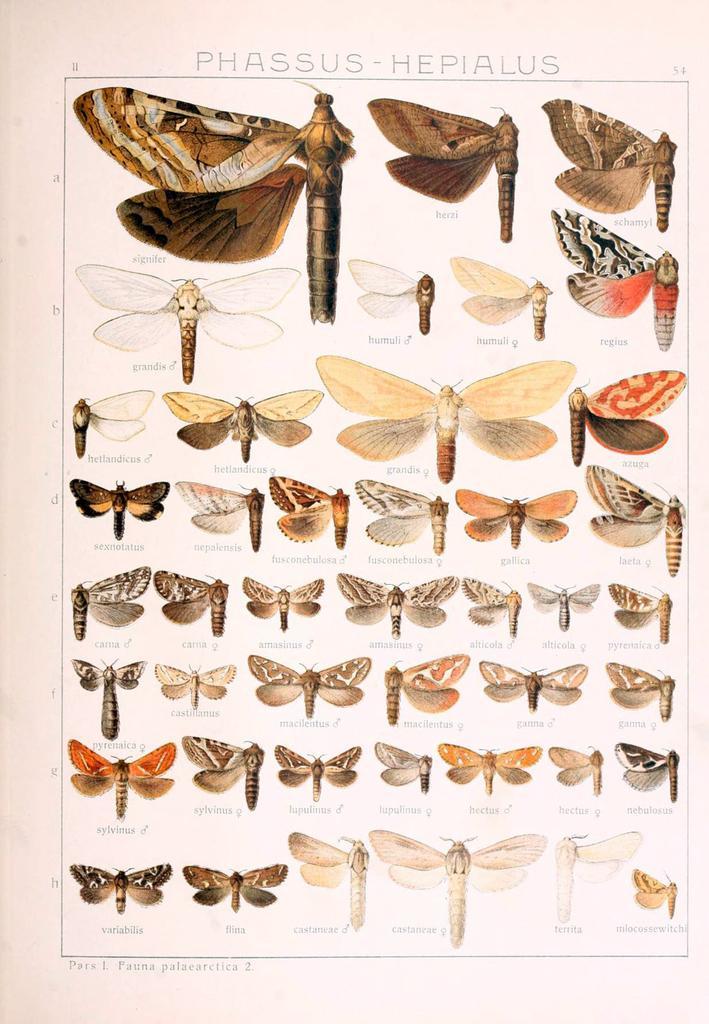In one or two sentences, can you explain what this image depicts? As we can see in the image there is a banner. On banner there is painting of few butterflies and there is something written. 